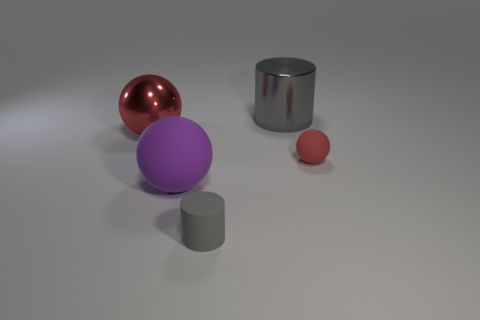Can you describe the color and texture of the objects in the image? Certainly! In the image, there is a large shiny red sphere with a smooth metallic texture, a purple matte sphere, a small shiny red sphere, and two cylinders with a metallic texture—one large and gray and the other smaller and in a shade that is a mixture of gray and a tint of purple. 